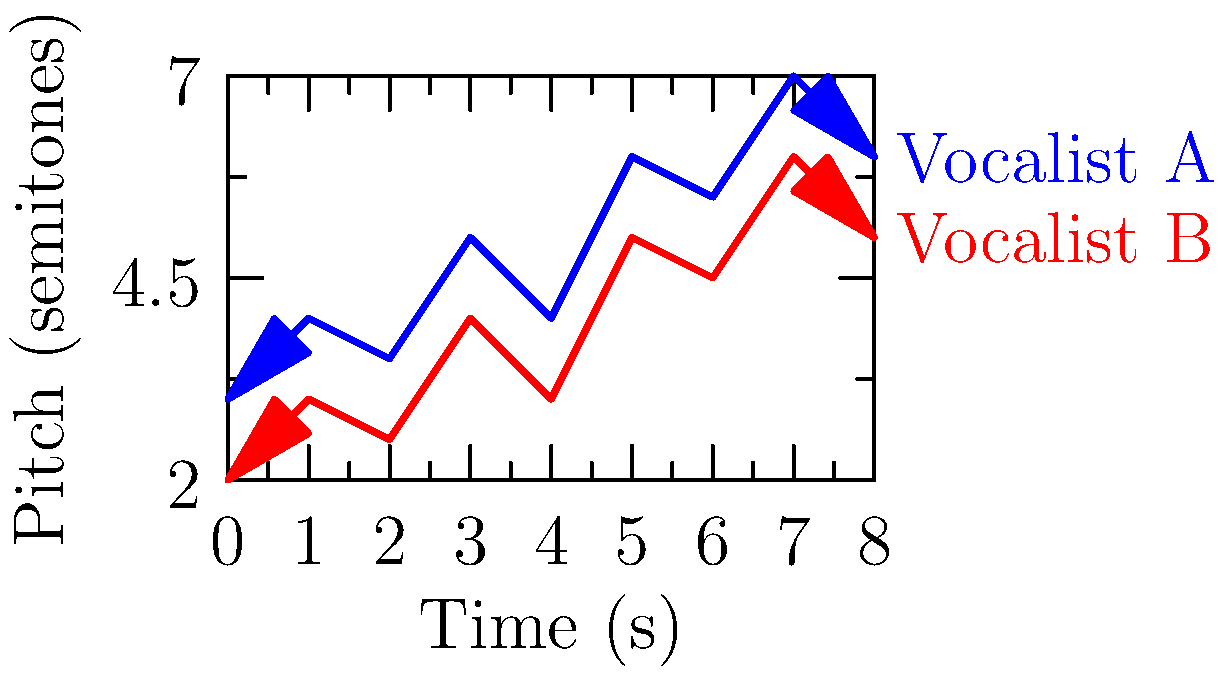As a record producer, you're working with two vocalists on a new track. The melodic contour plot above shows their pitch patterns over time. Based on this data, which vocalist would you recommend for a song that requires more dynamic vocal range and expressiveness? To determine which vocalist demonstrates a more dynamic vocal range and expressiveness, we need to analyze the melodic contour plots:

1. Pitch range:
   - Vocalist A (blue): Ranges from approximately 3 to 7 semitones
   - Vocalist B (red): Ranges from approximately 2 to 6 semitones

2. Pitch variation:
   - Vocalist A shows more frequent and larger pitch changes
   - Vocalist B follows a similar pattern but with less extreme variations

3. Overall contour:
   - Vocalist A's line has more pronounced peaks and valleys
   - Vocalist B's line is smoother with less dramatic shifts

4. Starting and ending points:
   - Vocalist A starts higher and ends higher than Vocalist B
   - Vocalist A covers a wider total range over the course of the sample

5. Expressiveness:
   - The more varied contour of Vocalist A suggests greater expressiveness in their performance

Based on these observations, Vocalist A demonstrates a more dynamic vocal range and greater expressiveness. Their pitch patterns show more variation, a wider overall range, and more dramatic shifts, which are typically associated with a more expressive vocal performance.
Answer: Vocalist A 